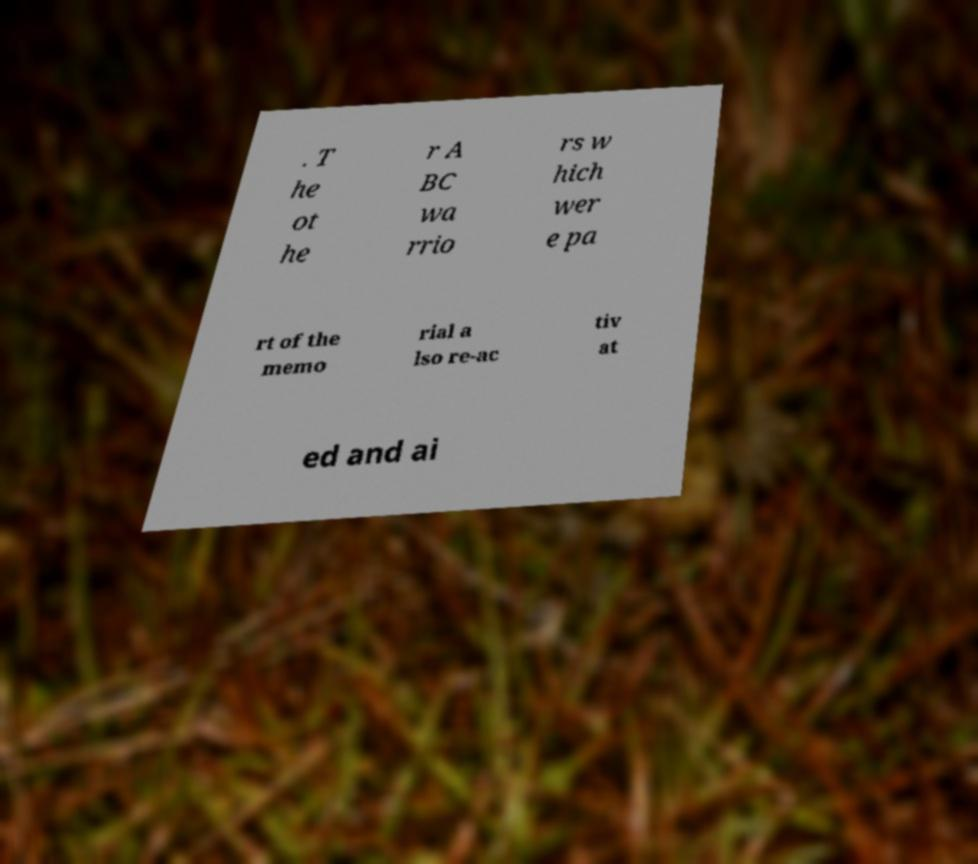I need the written content from this picture converted into text. Can you do that? . T he ot he r A BC wa rrio rs w hich wer e pa rt of the memo rial a lso re-ac tiv at ed and ai 